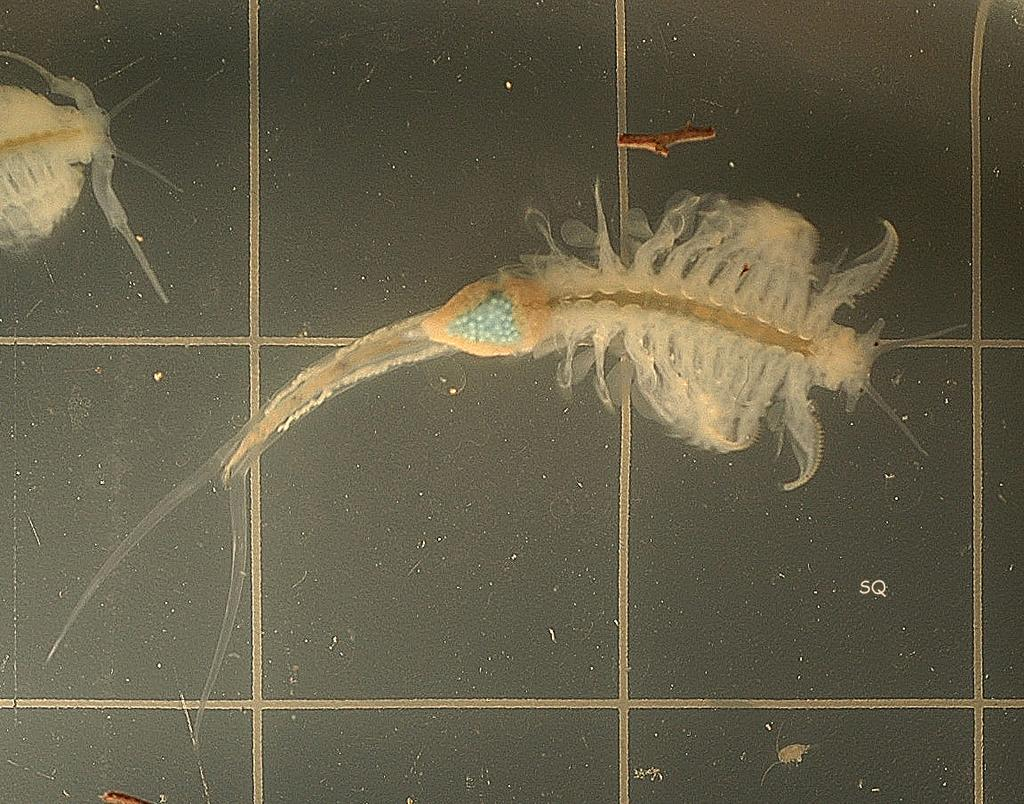What type of environment is depicted in the image? The image shows a water environment. What can be found in the water in the image? There are organisms in the water in the image. Where is the parcel being delivered by the carriage in the image? There is no parcel or carriage present in the image; it features organisms in a water environment. 